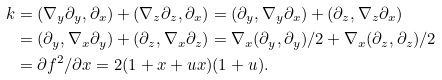Convert formula to latex. <formula><loc_0><loc_0><loc_500><loc_500>k & = ( \nabla _ { y } \partial _ { y } , \partial _ { x } ) + ( \nabla _ { z } \partial _ { z } , \partial _ { x } ) = ( \partial _ { y } , \nabla _ { y } \partial _ { x } ) + ( \partial _ { z } , \nabla _ { z } \partial _ { x } ) \\ & = ( \partial _ { y } , \nabla _ { x } \partial _ { y } ) + ( \partial _ { z } , \nabla _ { x } \partial _ { z } ) = \nabla _ { x } ( \partial _ { y } , \partial _ { y } ) / 2 + \nabla _ { x } ( \partial _ { z } , \partial _ { z } ) / 2 \\ & = \partial f ^ { 2 } / \partial x = 2 ( 1 + x + u x ) ( 1 + u ) .</formula> 